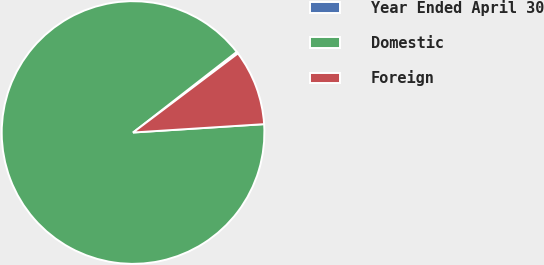Convert chart. <chart><loc_0><loc_0><loc_500><loc_500><pie_chart><fcel>Year Ended April 30<fcel>Domestic<fcel>Foreign<nl><fcel>0.24%<fcel>90.49%<fcel>9.27%<nl></chart> 